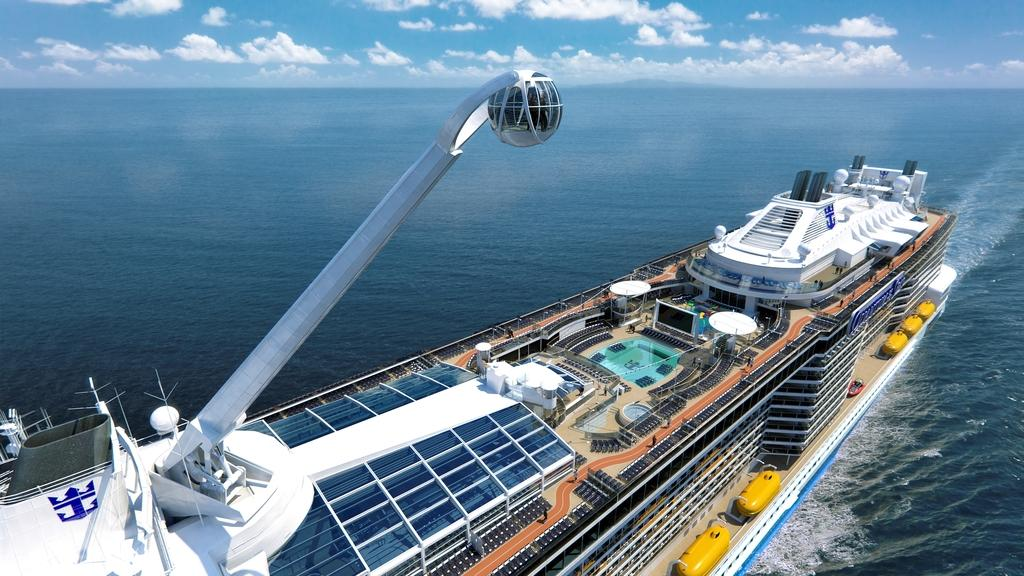What is the main subject of the image? The main subject of the image is a ship. Where is the ship located in the image? The ship is on the water in the image. What can be seen in the background of the image? Sky is visible in the background of the image. What is the condition of the sky in the image? Clouds are present in the sky in the image. What type of drink is being served on the ship in the image? There is no indication of any drinks being served on the ship in the image. 